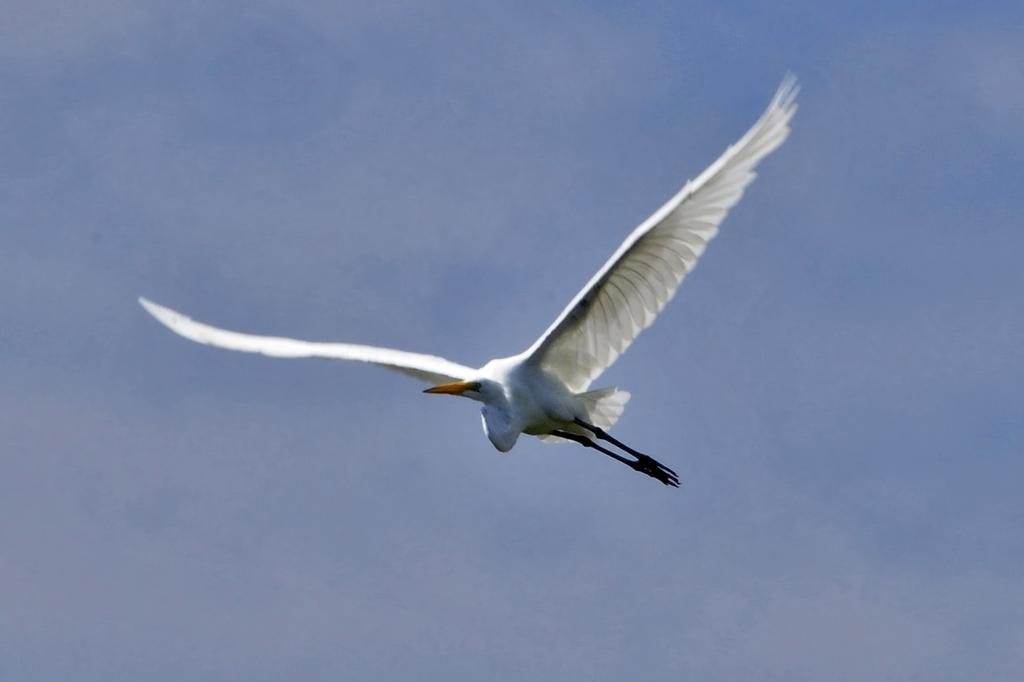What animal is present in the image? There is a white crane in the image. What is the crane doing in the image? The crane is flying in the image. How would you describe the sky in the image? The sky is blue and cloudy in the image. Can you see any boats in the image? There are no boats present in the image. Is there a bomb visible in the image? There is no bomb present in the image. 